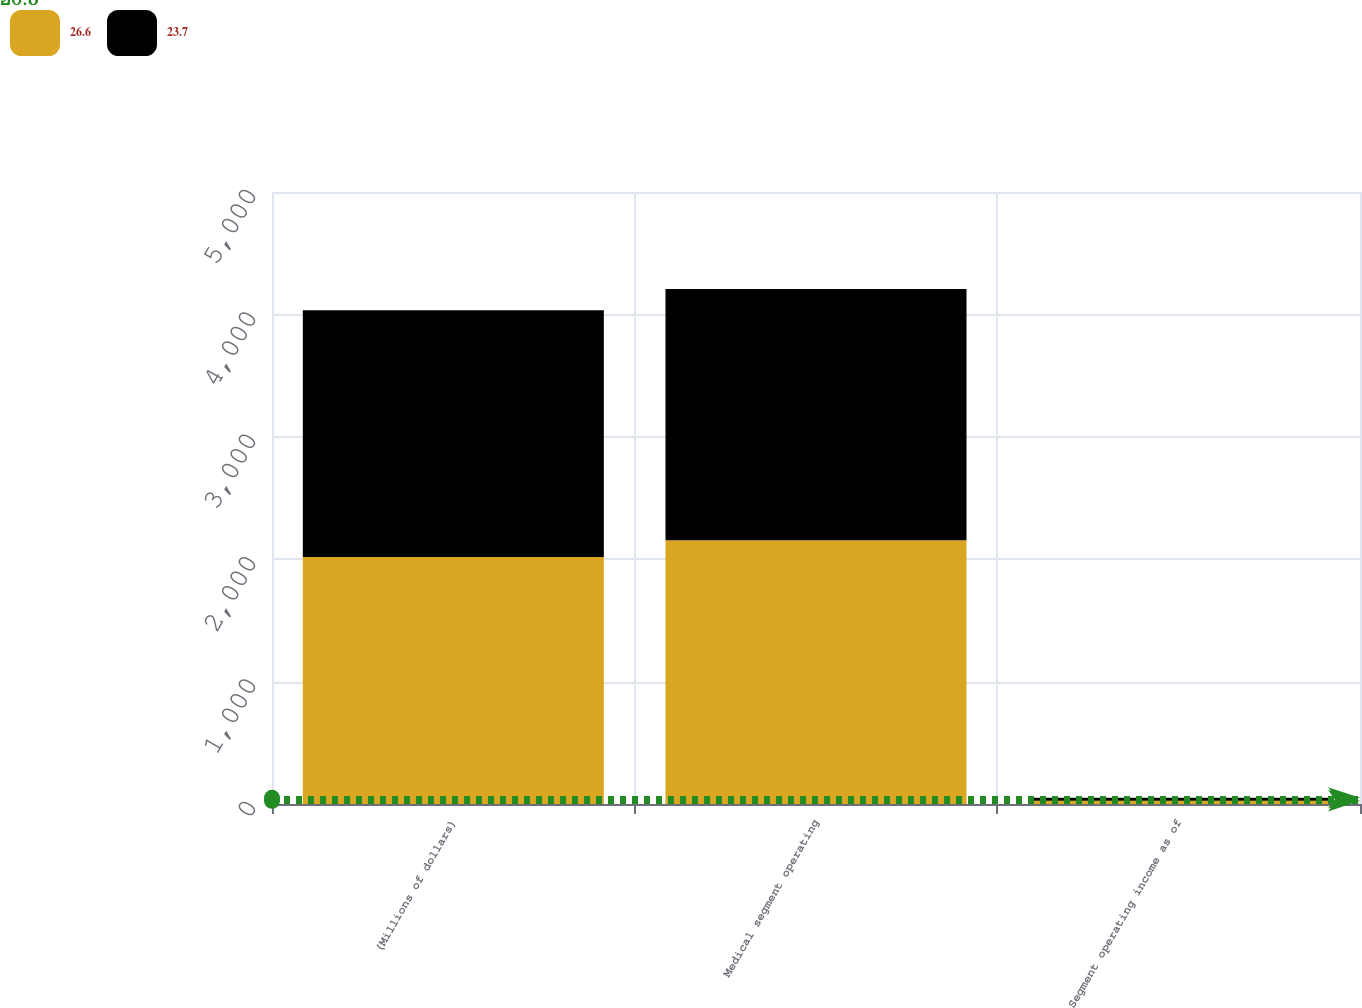Convert chart. <chart><loc_0><loc_0><loc_500><loc_500><stacked_bar_chart><ecel><fcel>(Millions of dollars)<fcel>Medical segment operating<fcel>Segment operating income as of<nl><fcel>26.6<fcel>2017<fcel>2155<fcel>26.6<nl><fcel>23.7<fcel>2016<fcel>2052<fcel>23.7<nl></chart> 